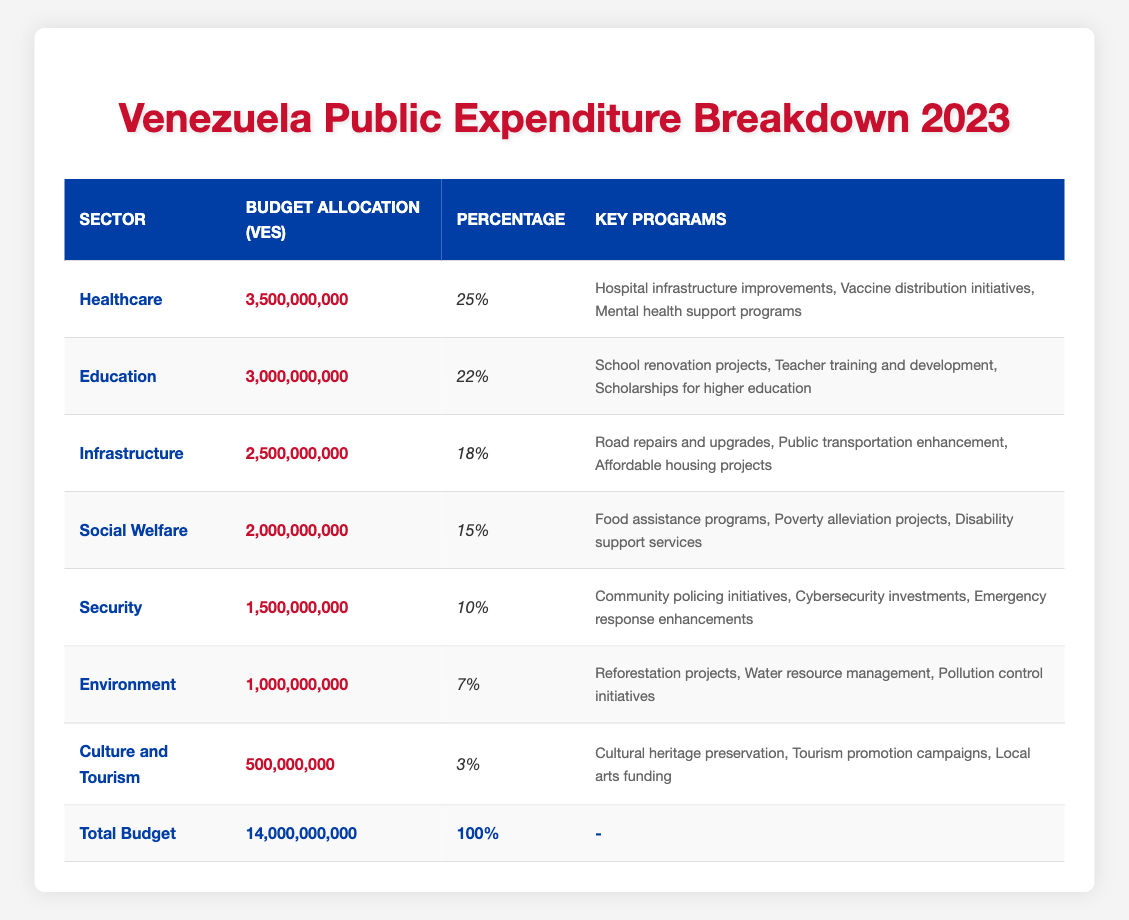What is the budget allocation for the Education sector? According to the table, the Education sector has a budget allocation of 3,000,000,000 VES.
Answer: 3,000,000,000 VES Which sector has the highest budget allocation? The table shows that the Healthcare sector, with a budget allocation of 3,500,000,000 VES, has the highest allocation among all sectors.
Answer: Healthcare What percentage of the total budget is allocated to the Social Welfare sector? The Social Welfare sector is allocated 15% of the total budget, as indicated in the table.
Answer: 15% What is the total budget allocation for both Environment and Culture and Tourism sectors combined? The Environment sector has a budget of 1,000,000,000 VES, and the Culture and Tourism sector has 500,000,000 VES. Adding these gives 1,000,000,000 + 500,000,000 = 1,500,000,000 VES combined.
Answer: 1,500,000,000 VES Is the budget allocation for Security higher than that for Environment? The Security sector has a budget allocation of 1,500,000,000 VES, whereas the Environment sector has 1,000,000,000 VES. Since 1,500,000,000 is greater than 1,000,000,000, the statement is true.
Answer: Yes What percentage of the total budget does Healthcare and Education sectors share together? The Healthcare sector receives 25% and Education receives 22%. Together, they account for 25 + 22 = 47% of the total budget.
Answer: 47% What is the budget difference between the Infrastructure and Social Welfare sectors? The Infrastructure sector has a budget of 2,500,000,000 VES and Social Welfare has 2,000,000,000 VES. The difference is 2,500,000,000 - 2,000,000,000 = 500,000,000 VES.
Answer: 500,000,000 VES What percentage of the total budget is dedicated to Culture and Tourism? The table shows that the Culture and Tourism sector is allocated 3% of the total budget.
Answer: 3% If we combine the budgets for Security and Environment, how much would that be in total? The Security sector has a budget of 1,500,000,000 VES and the Environment sector has 1,000,000,000 VES. Adding these gives a total of 1,500,000,000 + 1,000,000,000 = 2,500,000,000 VES.
Answer: 2,500,000,000 VES Which sectors received less than 10% of the total budget? The only sector that received less than 10% of the total budget is the Culture and Tourism sector with 3%.
Answer: Culture and Tourism 